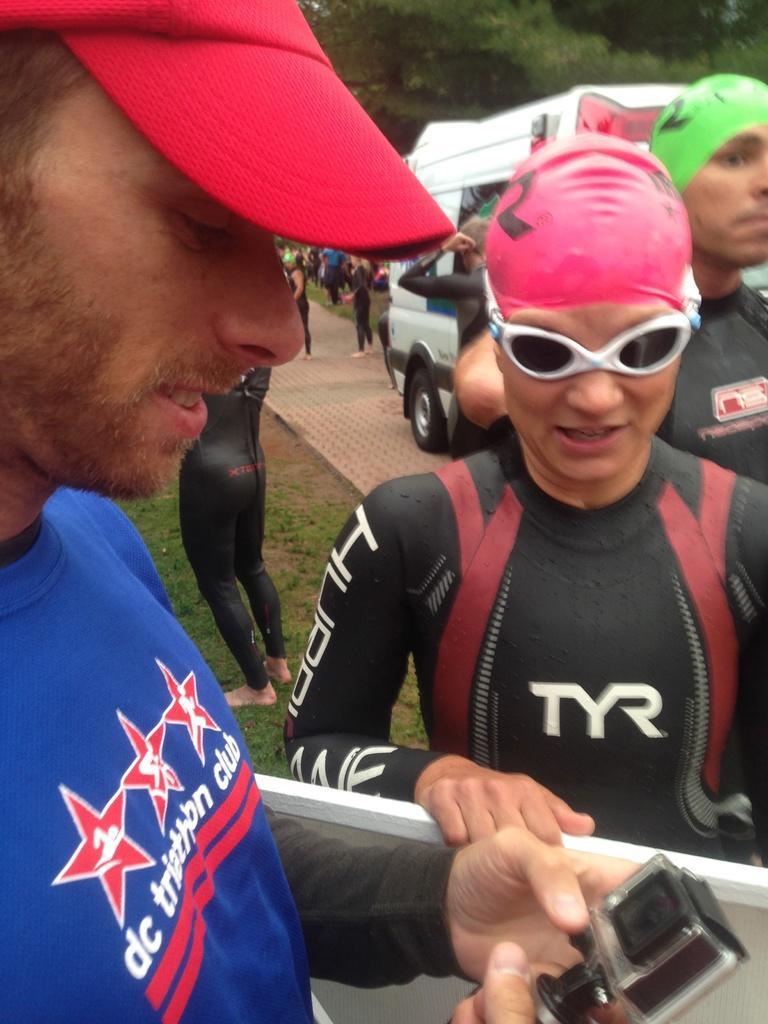In one or two sentences, can you explain what this image depicts? In this picture I can observe some people. On the left side I can observe a person wearing blue color T shirt and red color cap. On the right side there are swimmers in the swimming suits. In the background there are some people standing and I can observe a white color vehicle. There are trees in the background. 